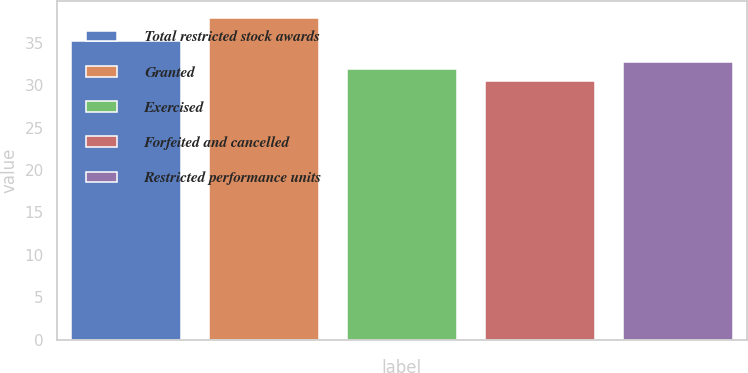<chart> <loc_0><loc_0><loc_500><loc_500><bar_chart><fcel>Total restricted stock awards<fcel>Granted<fcel>Exercised<fcel>Forfeited and cancelled<fcel>Restricted performance units<nl><fcel>35.18<fcel>37.94<fcel>31.94<fcel>30.44<fcel>32.69<nl></chart> 